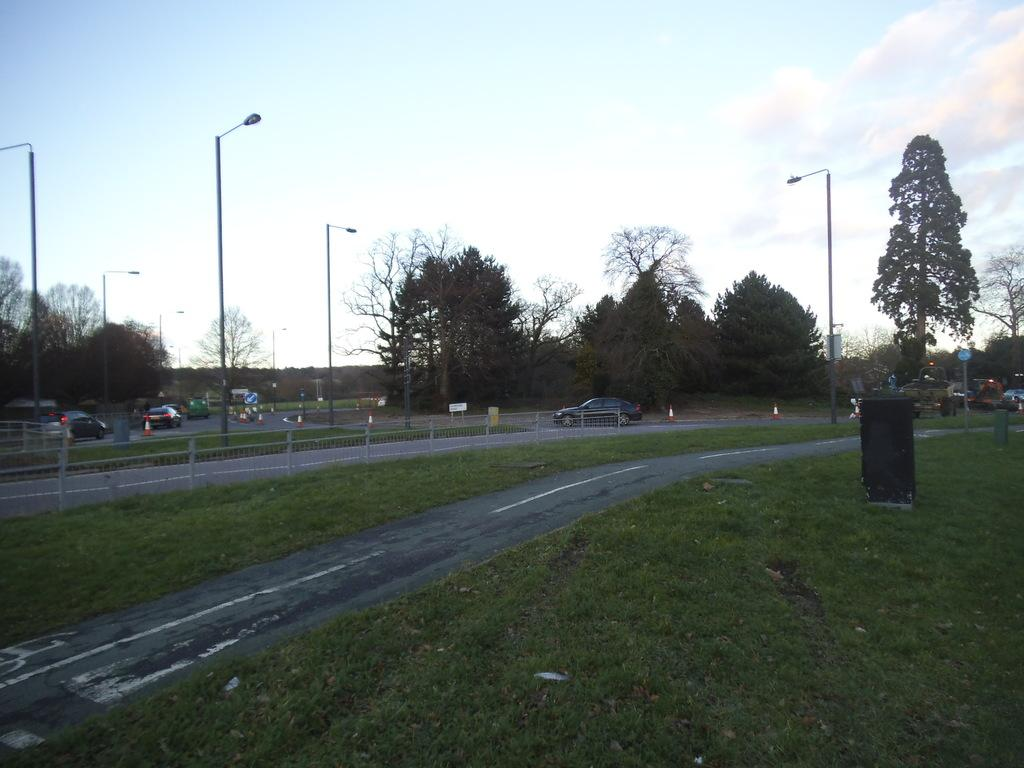What type of vegetation can be seen in the image? There is grass in the image. What type of structure is present in the image? There is a fence in the image. What other objects can be seen in the image? There are poles visible in the image. What can be seen in the background of the image? In the background of the image, there are vehicles, trees, sign boards, lights, and clouds. What type of harmony is being played by the wind in the image? There is no wind or harmony present in the image; it features grass, a fence, poles, and various elements in the background. 